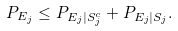<formula> <loc_0><loc_0><loc_500><loc_500>P _ { E _ { j } } & \leq P _ { E _ { j } | S _ { j } ^ { c } } + P _ { E _ { j } | S _ { j } } .</formula> 